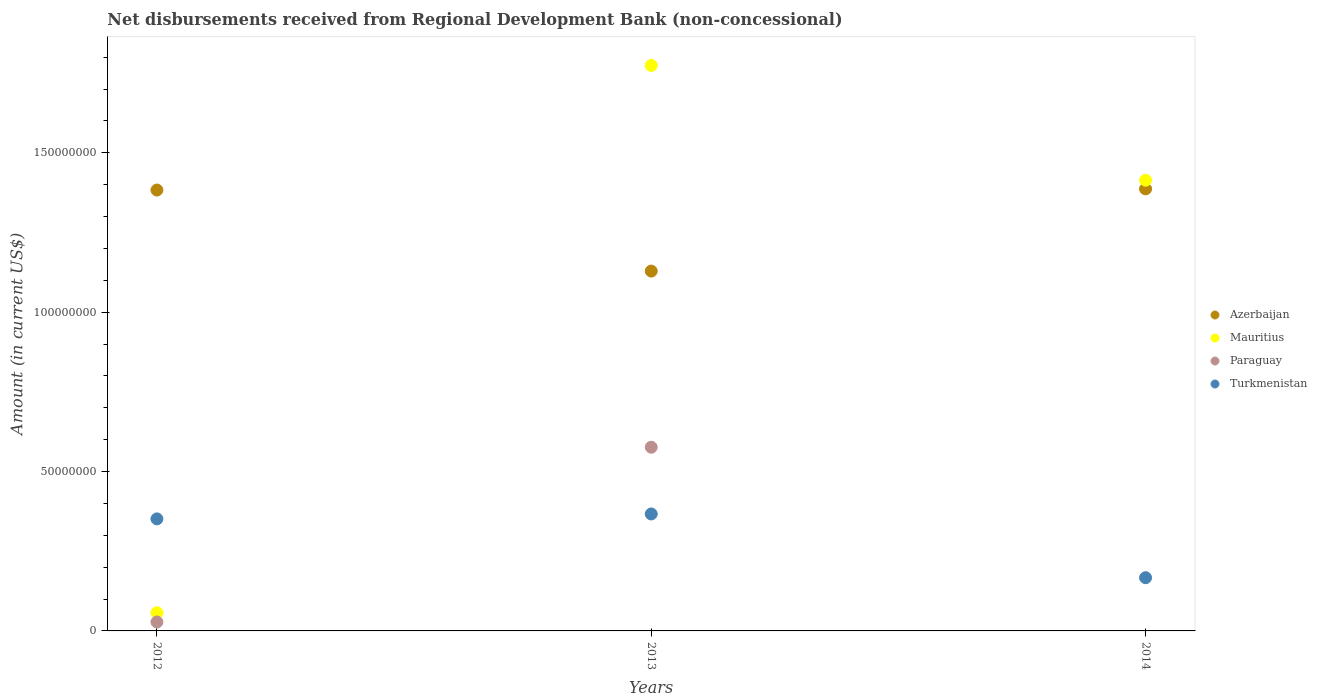How many different coloured dotlines are there?
Your answer should be compact. 4. What is the amount of disbursements received from Regional Development Bank in Mauritius in 2014?
Provide a succinct answer. 1.41e+08. Across all years, what is the maximum amount of disbursements received from Regional Development Bank in Turkmenistan?
Keep it short and to the point. 3.67e+07. What is the total amount of disbursements received from Regional Development Bank in Mauritius in the graph?
Offer a very short reply. 3.25e+08. What is the difference between the amount of disbursements received from Regional Development Bank in Azerbaijan in 2012 and that in 2014?
Provide a short and direct response. -3.71e+05. What is the difference between the amount of disbursements received from Regional Development Bank in Paraguay in 2013 and the amount of disbursements received from Regional Development Bank in Mauritius in 2014?
Make the answer very short. -8.38e+07. What is the average amount of disbursements received from Regional Development Bank in Azerbaijan per year?
Your answer should be compact. 1.30e+08. In the year 2012, what is the difference between the amount of disbursements received from Regional Development Bank in Mauritius and amount of disbursements received from Regional Development Bank in Turkmenistan?
Provide a succinct answer. -2.94e+07. What is the ratio of the amount of disbursements received from Regional Development Bank in Turkmenistan in 2012 to that in 2013?
Provide a succinct answer. 0.96. Is the amount of disbursements received from Regional Development Bank in Paraguay in 2012 less than that in 2013?
Offer a terse response. Yes. What is the difference between the highest and the second highest amount of disbursements received from Regional Development Bank in Mauritius?
Keep it short and to the point. 3.60e+07. What is the difference between the highest and the lowest amount of disbursements received from Regional Development Bank in Azerbaijan?
Keep it short and to the point. 2.58e+07. In how many years, is the amount of disbursements received from Regional Development Bank in Paraguay greater than the average amount of disbursements received from Regional Development Bank in Paraguay taken over all years?
Your response must be concise. 1. Is the sum of the amount of disbursements received from Regional Development Bank in Azerbaijan in 2012 and 2013 greater than the maximum amount of disbursements received from Regional Development Bank in Turkmenistan across all years?
Keep it short and to the point. Yes. Is it the case that in every year, the sum of the amount of disbursements received from Regional Development Bank in Mauritius and amount of disbursements received from Regional Development Bank in Turkmenistan  is greater than the amount of disbursements received from Regional Development Bank in Paraguay?
Give a very brief answer. Yes. Does the amount of disbursements received from Regional Development Bank in Mauritius monotonically increase over the years?
Provide a succinct answer. No. Is the amount of disbursements received from Regional Development Bank in Azerbaijan strictly greater than the amount of disbursements received from Regional Development Bank in Mauritius over the years?
Provide a succinct answer. No. How many dotlines are there?
Your response must be concise. 4. What is the difference between two consecutive major ticks on the Y-axis?
Ensure brevity in your answer.  5.00e+07. Does the graph contain grids?
Your answer should be compact. No. How many legend labels are there?
Ensure brevity in your answer.  4. What is the title of the graph?
Offer a terse response. Net disbursements received from Regional Development Bank (non-concessional). What is the label or title of the X-axis?
Offer a very short reply. Years. What is the Amount (in current US$) of Azerbaijan in 2012?
Provide a short and direct response. 1.38e+08. What is the Amount (in current US$) of Mauritius in 2012?
Your answer should be compact. 5.70e+06. What is the Amount (in current US$) of Paraguay in 2012?
Offer a very short reply. 2.80e+06. What is the Amount (in current US$) in Turkmenistan in 2012?
Keep it short and to the point. 3.51e+07. What is the Amount (in current US$) of Azerbaijan in 2013?
Your answer should be very brief. 1.13e+08. What is the Amount (in current US$) in Mauritius in 2013?
Offer a terse response. 1.77e+08. What is the Amount (in current US$) of Paraguay in 2013?
Make the answer very short. 5.76e+07. What is the Amount (in current US$) in Turkmenistan in 2013?
Offer a terse response. 3.67e+07. What is the Amount (in current US$) of Azerbaijan in 2014?
Give a very brief answer. 1.39e+08. What is the Amount (in current US$) of Mauritius in 2014?
Ensure brevity in your answer.  1.41e+08. What is the Amount (in current US$) in Turkmenistan in 2014?
Offer a terse response. 1.67e+07. Across all years, what is the maximum Amount (in current US$) of Azerbaijan?
Keep it short and to the point. 1.39e+08. Across all years, what is the maximum Amount (in current US$) of Mauritius?
Give a very brief answer. 1.77e+08. Across all years, what is the maximum Amount (in current US$) in Paraguay?
Ensure brevity in your answer.  5.76e+07. Across all years, what is the maximum Amount (in current US$) of Turkmenistan?
Offer a very short reply. 3.67e+07. Across all years, what is the minimum Amount (in current US$) of Azerbaijan?
Give a very brief answer. 1.13e+08. Across all years, what is the minimum Amount (in current US$) in Mauritius?
Give a very brief answer. 5.70e+06. Across all years, what is the minimum Amount (in current US$) in Paraguay?
Make the answer very short. 0. Across all years, what is the minimum Amount (in current US$) of Turkmenistan?
Your answer should be compact. 1.67e+07. What is the total Amount (in current US$) in Azerbaijan in the graph?
Make the answer very short. 3.90e+08. What is the total Amount (in current US$) of Mauritius in the graph?
Offer a very short reply. 3.25e+08. What is the total Amount (in current US$) in Paraguay in the graph?
Keep it short and to the point. 6.04e+07. What is the total Amount (in current US$) of Turkmenistan in the graph?
Ensure brevity in your answer.  8.85e+07. What is the difference between the Amount (in current US$) of Azerbaijan in 2012 and that in 2013?
Ensure brevity in your answer.  2.54e+07. What is the difference between the Amount (in current US$) of Mauritius in 2012 and that in 2013?
Provide a succinct answer. -1.72e+08. What is the difference between the Amount (in current US$) in Paraguay in 2012 and that in 2013?
Your answer should be very brief. -5.48e+07. What is the difference between the Amount (in current US$) of Turkmenistan in 2012 and that in 2013?
Offer a terse response. -1.55e+06. What is the difference between the Amount (in current US$) in Azerbaijan in 2012 and that in 2014?
Make the answer very short. -3.71e+05. What is the difference between the Amount (in current US$) of Mauritius in 2012 and that in 2014?
Provide a succinct answer. -1.36e+08. What is the difference between the Amount (in current US$) in Turkmenistan in 2012 and that in 2014?
Offer a terse response. 1.85e+07. What is the difference between the Amount (in current US$) in Azerbaijan in 2013 and that in 2014?
Give a very brief answer. -2.58e+07. What is the difference between the Amount (in current US$) of Mauritius in 2013 and that in 2014?
Offer a very short reply. 3.60e+07. What is the difference between the Amount (in current US$) of Turkmenistan in 2013 and that in 2014?
Offer a very short reply. 2.00e+07. What is the difference between the Amount (in current US$) of Azerbaijan in 2012 and the Amount (in current US$) of Mauritius in 2013?
Provide a succinct answer. -3.91e+07. What is the difference between the Amount (in current US$) of Azerbaijan in 2012 and the Amount (in current US$) of Paraguay in 2013?
Offer a terse response. 8.07e+07. What is the difference between the Amount (in current US$) in Azerbaijan in 2012 and the Amount (in current US$) in Turkmenistan in 2013?
Your answer should be compact. 1.02e+08. What is the difference between the Amount (in current US$) of Mauritius in 2012 and the Amount (in current US$) of Paraguay in 2013?
Make the answer very short. -5.19e+07. What is the difference between the Amount (in current US$) of Mauritius in 2012 and the Amount (in current US$) of Turkmenistan in 2013?
Your response must be concise. -3.10e+07. What is the difference between the Amount (in current US$) in Paraguay in 2012 and the Amount (in current US$) in Turkmenistan in 2013?
Your answer should be very brief. -3.39e+07. What is the difference between the Amount (in current US$) of Azerbaijan in 2012 and the Amount (in current US$) of Mauritius in 2014?
Your response must be concise. -3.09e+06. What is the difference between the Amount (in current US$) in Azerbaijan in 2012 and the Amount (in current US$) in Turkmenistan in 2014?
Ensure brevity in your answer.  1.22e+08. What is the difference between the Amount (in current US$) of Mauritius in 2012 and the Amount (in current US$) of Turkmenistan in 2014?
Offer a terse response. -1.10e+07. What is the difference between the Amount (in current US$) of Paraguay in 2012 and the Amount (in current US$) of Turkmenistan in 2014?
Make the answer very short. -1.39e+07. What is the difference between the Amount (in current US$) of Azerbaijan in 2013 and the Amount (in current US$) of Mauritius in 2014?
Provide a short and direct response. -2.85e+07. What is the difference between the Amount (in current US$) in Azerbaijan in 2013 and the Amount (in current US$) in Turkmenistan in 2014?
Ensure brevity in your answer.  9.62e+07. What is the difference between the Amount (in current US$) of Mauritius in 2013 and the Amount (in current US$) of Turkmenistan in 2014?
Make the answer very short. 1.61e+08. What is the difference between the Amount (in current US$) in Paraguay in 2013 and the Amount (in current US$) in Turkmenistan in 2014?
Give a very brief answer. 4.09e+07. What is the average Amount (in current US$) of Azerbaijan per year?
Your answer should be compact. 1.30e+08. What is the average Amount (in current US$) of Mauritius per year?
Your answer should be very brief. 1.08e+08. What is the average Amount (in current US$) of Paraguay per year?
Provide a succinct answer. 2.01e+07. What is the average Amount (in current US$) in Turkmenistan per year?
Provide a short and direct response. 2.95e+07. In the year 2012, what is the difference between the Amount (in current US$) of Azerbaijan and Amount (in current US$) of Mauritius?
Your response must be concise. 1.33e+08. In the year 2012, what is the difference between the Amount (in current US$) of Azerbaijan and Amount (in current US$) of Paraguay?
Your answer should be compact. 1.36e+08. In the year 2012, what is the difference between the Amount (in current US$) in Azerbaijan and Amount (in current US$) in Turkmenistan?
Give a very brief answer. 1.03e+08. In the year 2012, what is the difference between the Amount (in current US$) in Mauritius and Amount (in current US$) in Paraguay?
Offer a terse response. 2.90e+06. In the year 2012, what is the difference between the Amount (in current US$) in Mauritius and Amount (in current US$) in Turkmenistan?
Provide a short and direct response. -2.94e+07. In the year 2012, what is the difference between the Amount (in current US$) in Paraguay and Amount (in current US$) in Turkmenistan?
Offer a terse response. -3.23e+07. In the year 2013, what is the difference between the Amount (in current US$) in Azerbaijan and Amount (in current US$) in Mauritius?
Make the answer very short. -6.45e+07. In the year 2013, what is the difference between the Amount (in current US$) in Azerbaijan and Amount (in current US$) in Paraguay?
Offer a terse response. 5.53e+07. In the year 2013, what is the difference between the Amount (in current US$) of Azerbaijan and Amount (in current US$) of Turkmenistan?
Your answer should be very brief. 7.62e+07. In the year 2013, what is the difference between the Amount (in current US$) in Mauritius and Amount (in current US$) in Paraguay?
Your answer should be compact. 1.20e+08. In the year 2013, what is the difference between the Amount (in current US$) of Mauritius and Amount (in current US$) of Turkmenistan?
Provide a succinct answer. 1.41e+08. In the year 2013, what is the difference between the Amount (in current US$) in Paraguay and Amount (in current US$) in Turkmenistan?
Provide a short and direct response. 2.09e+07. In the year 2014, what is the difference between the Amount (in current US$) of Azerbaijan and Amount (in current US$) of Mauritius?
Make the answer very short. -2.72e+06. In the year 2014, what is the difference between the Amount (in current US$) of Azerbaijan and Amount (in current US$) of Turkmenistan?
Make the answer very short. 1.22e+08. In the year 2014, what is the difference between the Amount (in current US$) of Mauritius and Amount (in current US$) of Turkmenistan?
Give a very brief answer. 1.25e+08. What is the ratio of the Amount (in current US$) of Azerbaijan in 2012 to that in 2013?
Provide a succinct answer. 1.23. What is the ratio of the Amount (in current US$) of Mauritius in 2012 to that in 2013?
Ensure brevity in your answer.  0.03. What is the ratio of the Amount (in current US$) of Paraguay in 2012 to that in 2013?
Offer a terse response. 0.05. What is the ratio of the Amount (in current US$) of Turkmenistan in 2012 to that in 2013?
Your answer should be very brief. 0.96. What is the ratio of the Amount (in current US$) of Azerbaijan in 2012 to that in 2014?
Provide a short and direct response. 1. What is the ratio of the Amount (in current US$) of Mauritius in 2012 to that in 2014?
Your response must be concise. 0.04. What is the ratio of the Amount (in current US$) of Turkmenistan in 2012 to that in 2014?
Your answer should be very brief. 2.11. What is the ratio of the Amount (in current US$) in Azerbaijan in 2013 to that in 2014?
Your answer should be compact. 0.81. What is the ratio of the Amount (in current US$) of Mauritius in 2013 to that in 2014?
Offer a terse response. 1.25. What is the ratio of the Amount (in current US$) in Turkmenistan in 2013 to that in 2014?
Make the answer very short. 2.2. What is the difference between the highest and the second highest Amount (in current US$) of Azerbaijan?
Provide a succinct answer. 3.71e+05. What is the difference between the highest and the second highest Amount (in current US$) in Mauritius?
Give a very brief answer. 3.60e+07. What is the difference between the highest and the second highest Amount (in current US$) of Turkmenistan?
Your response must be concise. 1.55e+06. What is the difference between the highest and the lowest Amount (in current US$) of Azerbaijan?
Your response must be concise. 2.58e+07. What is the difference between the highest and the lowest Amount (in current US$) of Mauritius?
Offer a terse response. 1.72e+08. What is the difference between the highest and the lowest Amount (in current US$) in Paraguay?
Make the answer very short. 5.76e+07. What is the difference between the highest and the lowest Amount (in current US$) of Turkmenistan?
Offer a very short reply. 2.00e+07. 